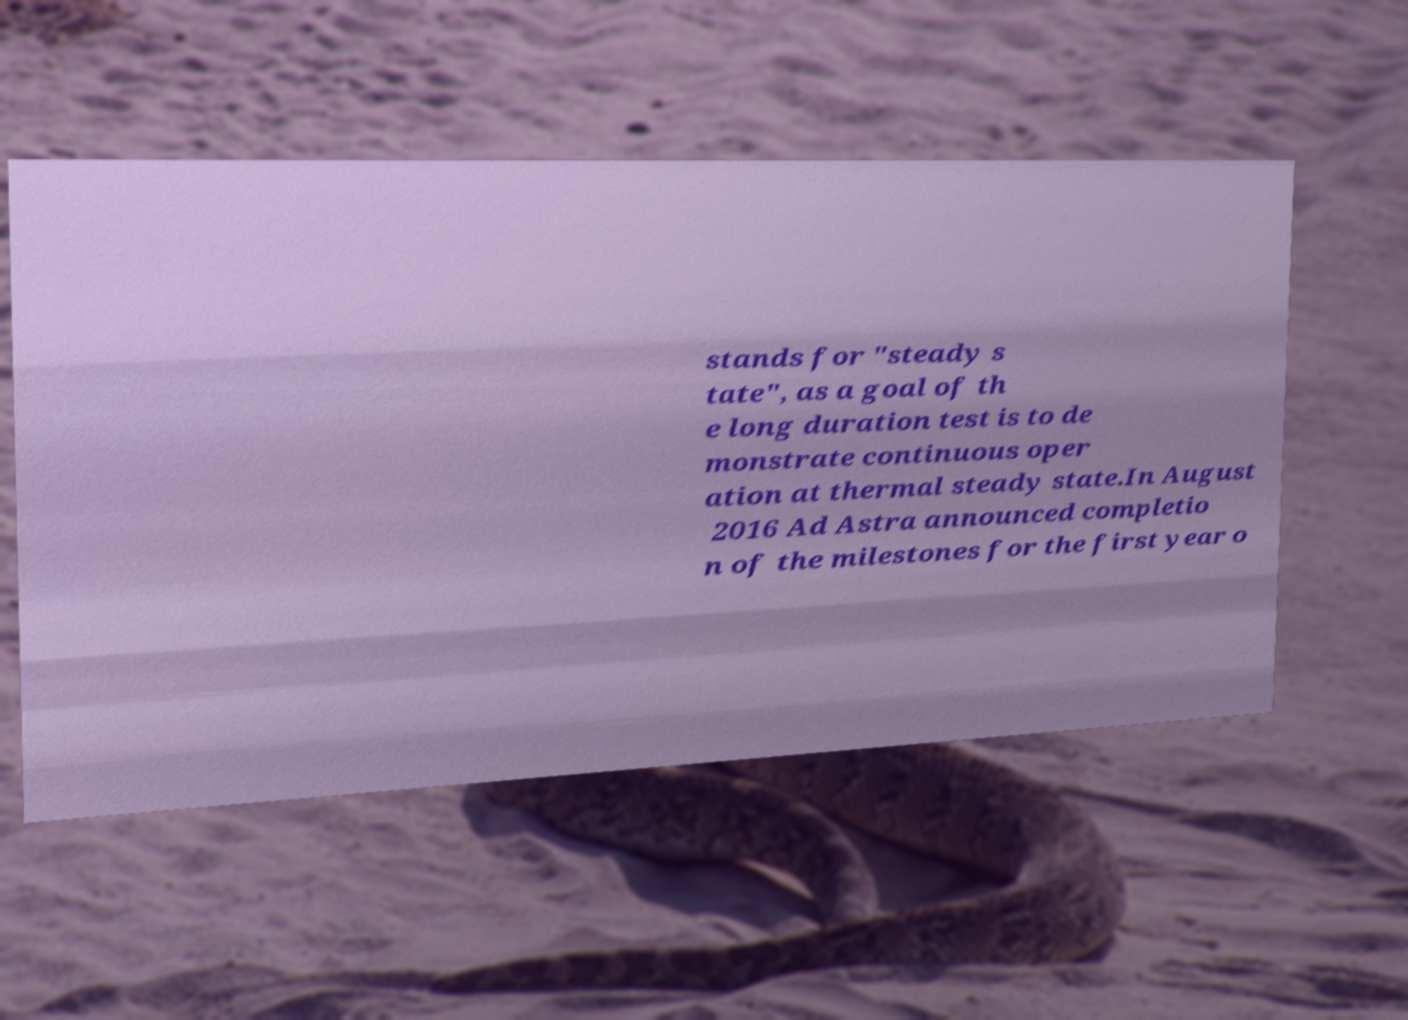I need the written content from this picture converted into text. Can you do that? stands for "steady s tate", as a goal of th e long duration test is to de monstrate continuous oper ation at thermal steady state.In August 2016 Ad Astra announced completio n of the milestones for the first year o 